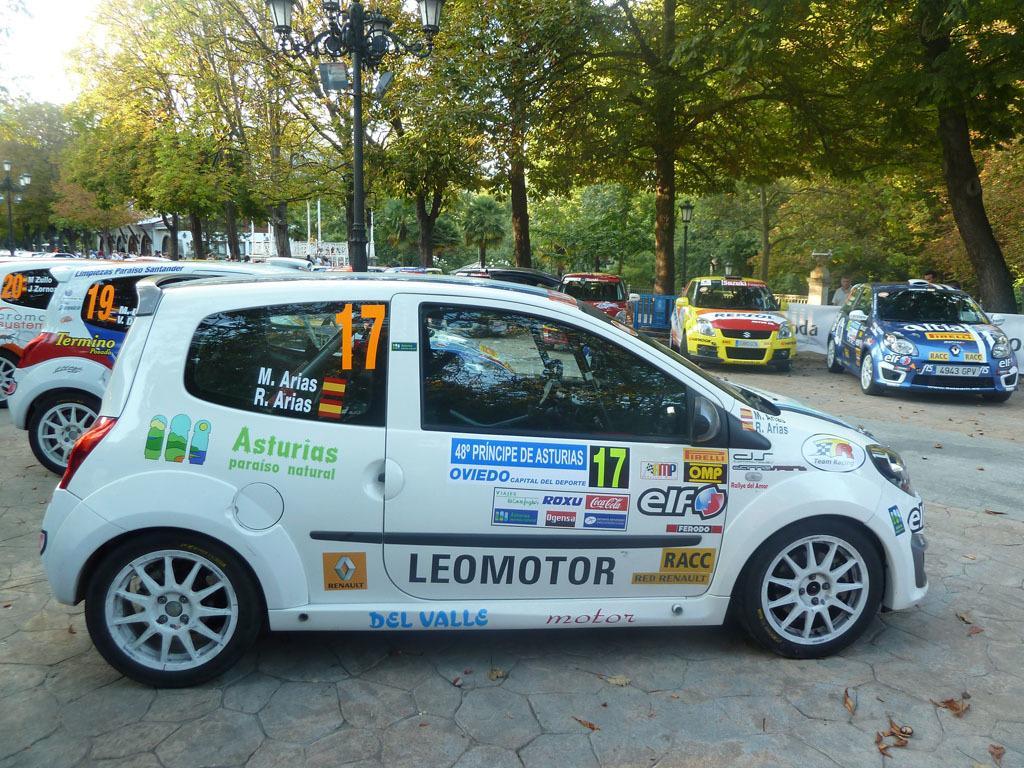Describe this image in one or two sentences. There are many cars. On the cars there are some posters. In the back there are many trees and street light poles. 